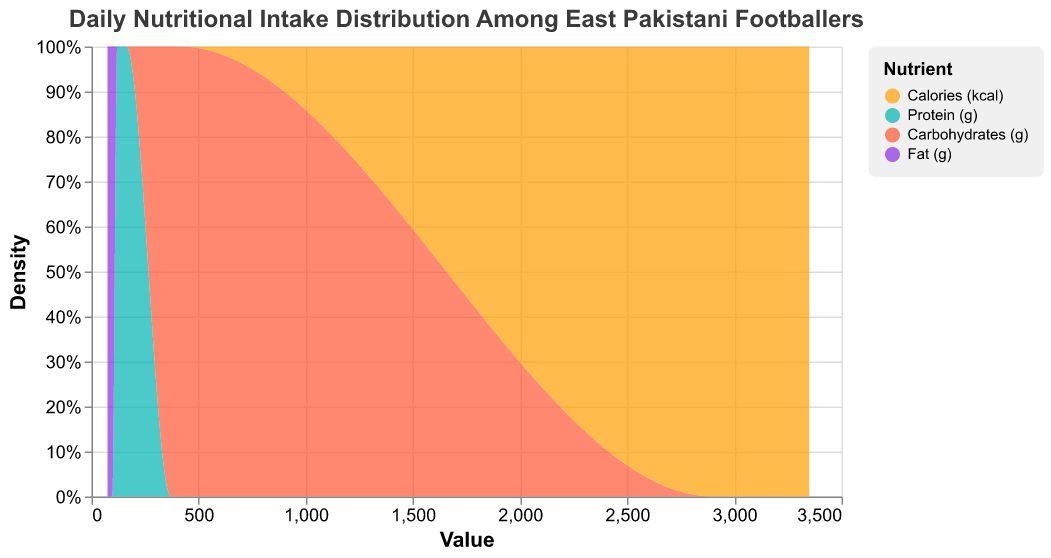What is the title of the figure? The title of the figure is prominently displayed at the top and provides context about the data being presented.
Answer: Daily Nutritional Intake Distribution Among East Pakistani Footballers What variable is represented on the x-axis? The x-axis represents the numerical value of nutritional intake variables. This can be seen from the axis label, which is 'Value'.
Answer: Value Which nutrient is represented in orange color? The nutrient represented in orange can be identified by looking at the color legend on the right side of the plot.
Answer: Calories (kcal) How are the y-axis values formatted? The y-axis values are in percentage format, as indicated by the '%' symbol on the y-axis label. This helps in normalizing the counts.
Answer: Percentage (%) What color represents the 'Fat (g)' nutrient? The color corresponding to 'Fat (g)' can be identified by referring to the legend on the right.
Answer: Purple Between ‘Calories (kcal)’ and ‘Protein (g)’, which has a larger maximum density? To determine this, one must examine the highest points of the density curves for both ‘Calories (kcal)’ and ‘Protein (g)’ and compare them.
Answer: Calories (kcal) Which nutrient has the least density variation? The nutrient with the least density variation will have the most uniform spread along the x-axis, meaning its curve is flatter compared to others.
Answer: Protein (g) For the day '2023-10-02', how do the values of Mari's 'Carbohydrates (g)' and 'Fat (g)' compare? Mari's intake for 'Carbohydrates (g)' on '2023-10-02' is 395, whereas for 'Fat (g)', it is 88. Comparing these two values shows which is higher.
Answer: Carbohydrates (g) What is the overall range of values for 'Calories (kcal)' across all players? To determine the range, identify the minimum and maximum values for 'Calories (kcal)' from the data points provided and find the difference.
Answer: 2900 to 3350 How does the nutritional intake of ‘Protein (g)’ compare to that of ‘Carbohydrates (g)’ in terms of density overlap? By examining the density plot, one can see how much the curves for 'Protein (g)' and 'Carbohydrates (g)' overlap, indicating similarity or difference in their distributions.
Answer: Moderate overlap but distinct peaks 